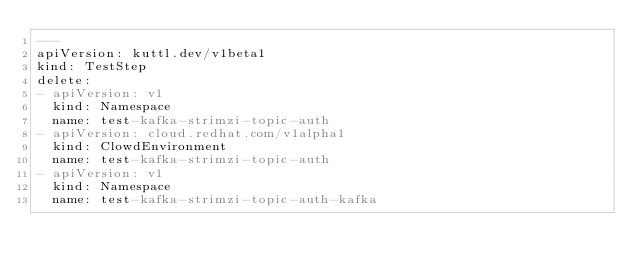Convert code to text. <code><loc_0><loc_0><loc_500><loc_500><_YAML_>---
apiVersion: kuttl.dev/v1beta1
kind: TestStep
delete:
- apiVersion: v1
  kind: Namespace
  name: test-kafka-strimzi-topic-auth
- apiVersion: cloud.redhat.com/v1alpha1
  kind: ClowdEnvironment
  name: test-kafka-strimzi-topic-auth
- apiVersion: v1
  kind: Namespace
  name: test-kafka-strimzi-topic-auth-kafka
</code> 